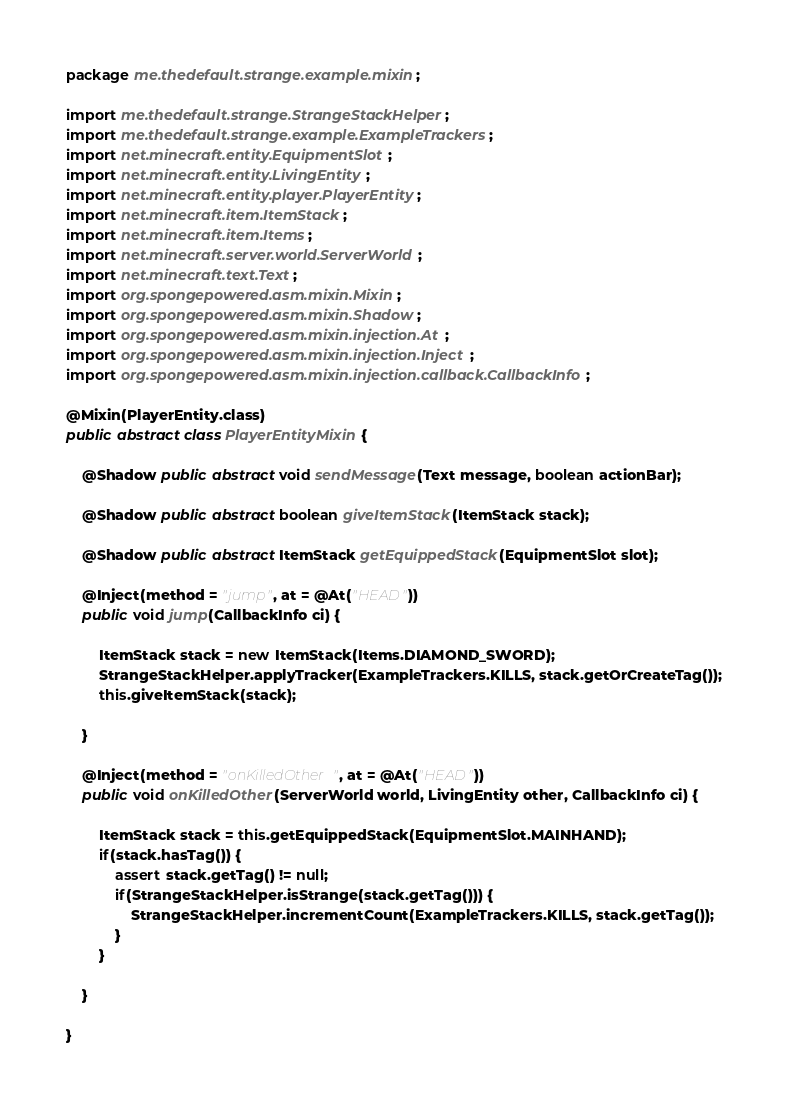<code> <loc_0><loc_0><loc_500><loc_500><_Java_>package me.thedefault.strange.example.mixin;

import me.thedefault.strange.StrangeStackHelper;
import me.thedefault.strange.example.ExampleTrackers;
import net.minecraft.entity.EquipmentSlot;
import net.minecraft.entity.LivingEntity;
import net.minecraft.entity.player.PlayerEntity;
import net.minecraft.item.ItemStack;
import net.minecraft.item.Items;
import net.minecraft.server.world.ServerWorld;
import net.minecraft.text.Text;
import org.spongepowered.asm.mixin.Mixin;
import org.spongepowered.asm.mixin.Shadow;
import org.spongepowered.asm.mixin.injection.At;
import org.spongepowered.asm.mixin.injection.Inject;
import org.spongepowered.asm.mixin.injection.callback.CallbackInfo;

@Mixin(PlayerEntity.class)
public abstract class PlayerEntityMixin {

    @Shadow public abstract void sendMessage(Text message, boolean actionBar);

    @Shadow public abstract boolean giveItemStack(ItemStack stack);

    @Shadow public abstract ItemStack getEquippedStack(EquipmentSlot slot);

    @Inject(method = "jump", at = @At("HEAD"))
    public void jump(CallbackInfo ci) {

        ItemStack stack = new ItemStack(Items.DIAMOND_SWORD);
        StrangeStackHelper.applyTracker(ExampleTrackers.KILLS, stack.getOrCreateTag());
        this.giveItemStack(stack);

    }

    @Inject(method = "onKilledOther", at = @At("HEAD"))
    public void onKilledOther(ServerWorld world, LivingEntity other, CallbackInfo ci) {

        ItemStack stack = this.getEquippedStack(EquipmentSlot.MAINHAND);
        if(stack.hasTag()) {
            assert stack.getTag() != null;
            if(StrangeStackHelper.isStrange(stack.getTag())) {
                StrangeStackHelper.incrementCount(ExampleTrackers.KILLS, stack.getTag());
            }
        }

    }

}
</code> 